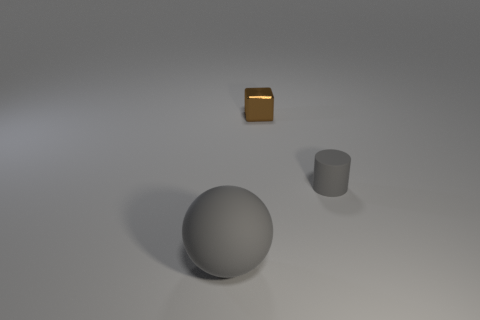Add 1 tiny cylinders. How many objects exist? 4 Subtract all cylinders. How many objects are left? 2 Add 2 small blocks. How many small blocks are left? 3 Add 2 big spheres. How many big spheres exist? 3 Subtract 0 green cylinders. How many objects are left? 3 Subtract all large red metal objects. Subtract all gray rubber objects. How many objects are left? 1 